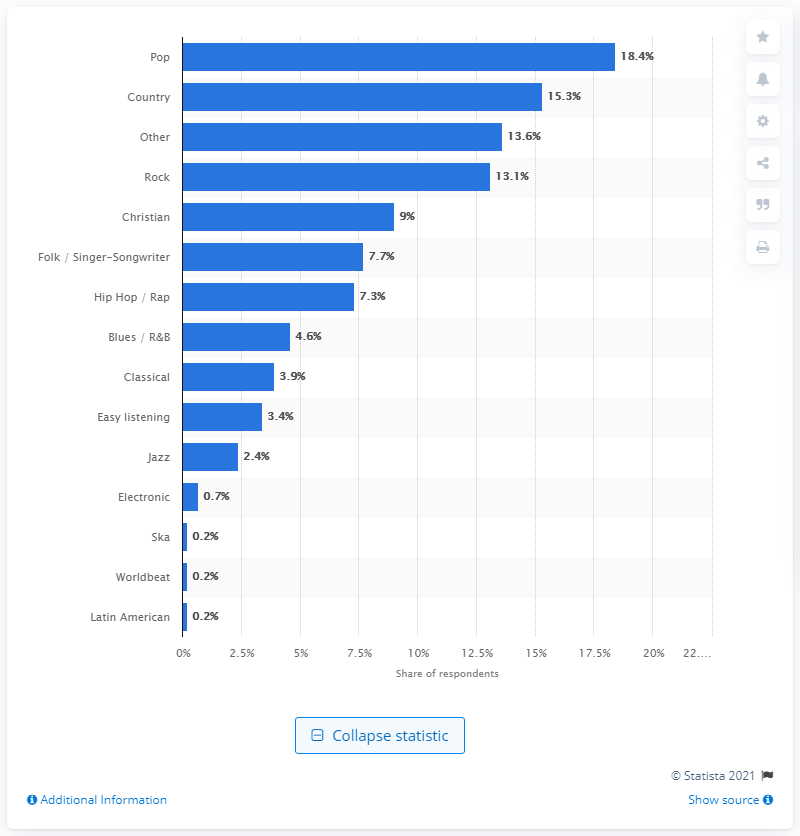Give some essential details in this illustration. According to the data, Pop was the second most consumed genre of music with 15.3 percent of all music songs consumed. 